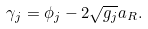<formula> <loc_0><loc_0><loc_500><loc_500>\gamma _ { j } = \phi _ { j } - 2 \sqrt { g _ { j } } a _ { R } .</formula> 